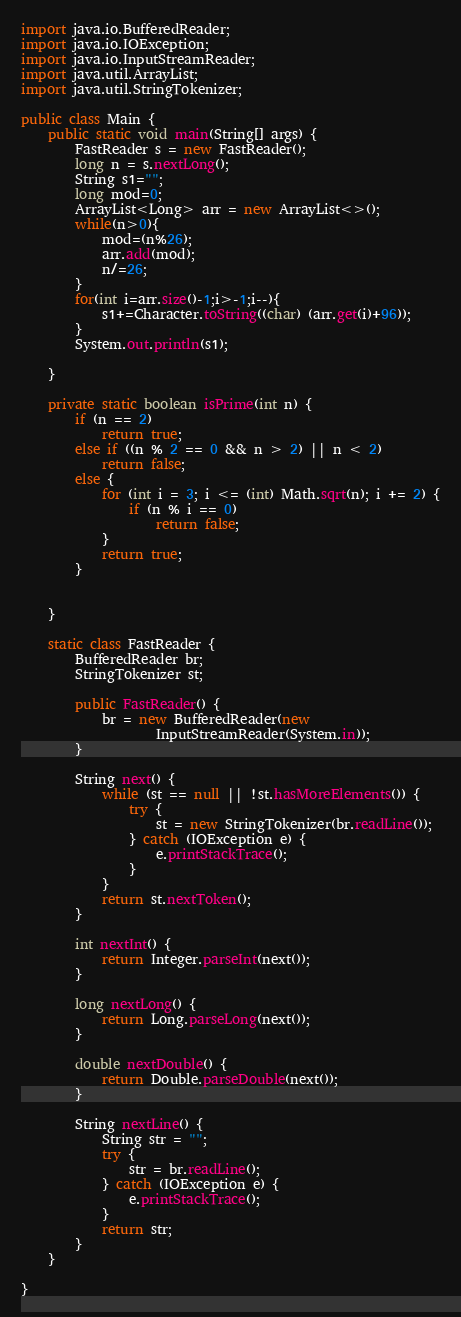Convert code to text. <code><loc_0><loc_0><loc_500><loc_500><_Java_>

import java.io.BufferedReader;
import java.io.IOException;
import java.io.InputStreamReader;
import java.util.ArrayList;
import java.util.StringTokenizer;

public class Main {
    public static void main(String[] args) {
        FastReader s = new FastReader();
        long n = s.nextLong();
        String s1="";
        long mod=0;
        ArrayList<Long> arr = new ArrayList<>();
        while(n>0){
            mod=(n%26);
            arr.add(mod);
            n/=26;
        }
        for(int i=arr.size()-1;i>-1;i--){
            s1+=Character.toString((char) (arr.get(i)+96));
        }
        System.out.println(s1);

    }

    private static boolean isPrime(int n) {
        if (n == 2)
            return true;
        else if ((n % 2 == 0 && n > 2) || n < 2)
            return false;
        else {
            for (int i = 3; i <= (int) Math.sqrt(n); i += 2) {
                if (n % i == 0)
                    return false;
            }
            return true;
        }


    }

    static class FastReader {
        BufferedReader br;
        StringTokenizer st;

        public FastReader() {
            br = new BufferedReader(new
                    InputStreamReader(System.in));
        }

        String next() {
            while (st == null || !st.hasMoreElements()) {
                try {
                    st = new StringTokenizer(br.readLine());
                } catch (IOException e) {
                    e.printStackTrace();
                }
            }
            return st.nextToken();
        }

        int nextInt() {
            return Integer.parseInt(next());
        }

        long nextLong() {
            return Long.parseLong(next());
        }

        double nextDouble() {
            return Double.parseDouble(next());
        }

        String nextLine() {
            String str = "";
            try {
                str = br.readLine();
            } catch (IOException e) {
                e.printStackTrace();
            }
            return str;
        }
    }

}</code> 